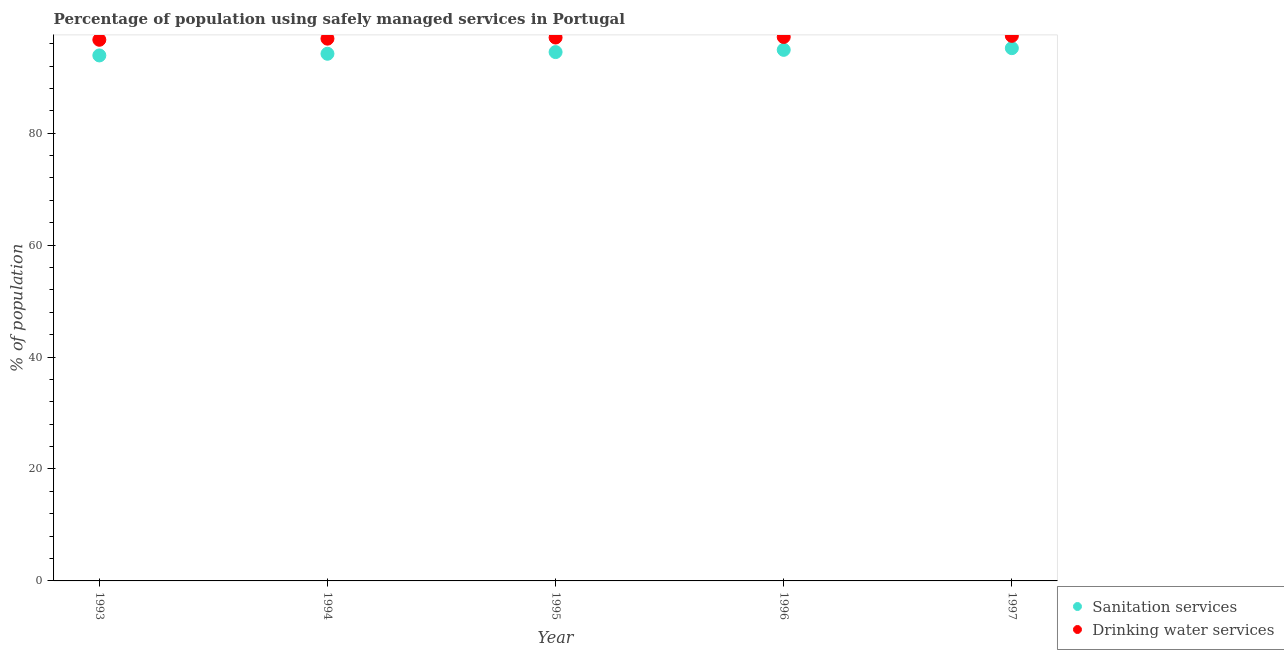How many different coloured dotlines are there?
Ensure brevity in your answer.  2. Is the number of dotlines equal to the number of legend labels?
Your response must be concise. Yes. What is the percentage of population who used sanitation services in 1995?
Your answer should be compact. 94.5. Across all years, what is the maximum percentage of population who used drinking water services?
Your response must be concise. 97.4. Across all years, what is the minimum percentage of population who used sanitation services?
Provide a succinct answer. 93.9. In which year was the percentage of population who used sanitation services maximum?
Provide a succinct answer. 1997. What is the total percentage of population who used drinking water services in the graph?
Give a very brief answer. 485.3. What is the difference between the percentage of population who used sanitation services in 1995 and that in 1996?
Give a very brief answer. -0.4. What is the difference between the percentage of population who used sanitation services in 1993 and the percentage of population who used drinking water services in 1996?
Your response must be concise. -3.3. What is the average percentage of population who used sanitation services per year?
Offer a very short reply. 94.54. In the year 1996, what is the difference between the percentage of population who used drinking water services and percentage of population who used sanitation services?
Your response must be concise. 2.3. In how many years, is the percentage of population who used sanitation services greater than 56 %?
Ensure brevity in your answer.  5. What is the ratio of the percentage of population who used drinking water services in 1994 to that in 1997?
Ensure brevity in your answer.  0.99. Is the percentage of population who used sanitation services in 1993 less than that in 1996?
Make the answer very short. Yes. Is the difference between the percentage of population who used sanitation services in 1993 and 1996 greater than the difference between the percentage of population who used drinking water services in 1993 and 1996?
Keep it short and to the point. No. What is the difference between the highest and the second highest percentage of population who used sanitation services?
Give a very brief answer. 0.3. What is the difference between the highest and the lowest percentage of population who used drinking water services?
Give a very brief answer. 0.7. In how many years, is the percentage of population who used drinking water services greater than the average percentage of population who used drinking water services taken over all years?
Ensure brevity in your answer.  3. Is the sum of the percentage of population who used drinking water services in 1994 and 1996 greater than the maximum percentage of population who used sanitation services across all years?
Offer a terse response. Yes. Is the percentage of population who used sanitation services strictly less than the percentage of population who used drinking water services over the years?
Your answer should be compact. Yes. How many years are there in the graph?
Your answer should be compact. 5. What is the difference between two consecutive major ticks on the Y-axis?
Your answer should be compact. 20. Are the values on the major ticks of Y-axis written in scientific E-notation?
Offer a very short reply. No. Does the graph contain any zero values?
Your answer should be very brief. No. Where does the legend appear in the graph?
Keep it short and to the point. Bottom right. How many legend labels are there?
Make the answer very short. 2. How are the legend labels stacked?
Ensure brevity in your answer.  Vertical. What is the title of the graph?
Keep it short and to the point. Percentage of population using safely managed services in Portugal. What is the label or title of the Y-axis?
Provide a succinct answer. % of population. What is the % of population of Sanitation services in 1993?
Offer a terse response. 93.9. What is the % of population in Drinking water services in 1993?
Your response must be concise. 96.7. What is the % of population in Sanitation services in 1994?
Make the answer very short. 94.2. What is the % of population in Drinking water services in 1994?
Keep it short and to the point. 96.9. What is the % of population in Sanitation services in 1995?
Keep it short and to the point. 94.5. What is the % of population of Drinking water services in 1995?
Offer a very short reply. 97.1. What is the % of population of Sanitation services in 1996?
Give a very brief answer. 94.9. What is the % of population in Drinking water services in 1996?
Provide a short and direct response. 97.2. What is the % of population in Sanitation services in 1997?
Make the answer very short. 95.2. What is the % of population of Drinking water services in 1997?
Give a very brief answer. 97.4. Across all years, what is the maximum % of population in Sanitation services?
Provide a short and direct response. 95.2. Across all years, what is the maximum % of population of Drinking water services?
Make the answer very short. 97.4. Across all years, what is the minimum % of population in Sanitation services?
Provide a short and direct response. 93.9. Across all years, what is the minimum % of population in Drinking water services?
Give a very brief answer. 96.7. What is the total % of population in Sanitation services in the graph?
Your response must be concise. 472.7. What is the total % of population of Drinking water services in the graph?
Make the answer very short. 485.3. What is the difference between the % of population in Sanitation services in 1993 and that in 1994?
Offer a very short reply. -0.3. What is the difference between the % of population of Sanitation services in 1993 and that in 1995?
Provide a short and direct response. -0.6. What is the difference between the % of population of Drinking water services in 1993 and that in 1995?
Ensure brevity in your answer.  -0.4. What is the difference between the % of population of Sanitation services in 1993 and that in 1996?
Your answer should be very brief. -1. What is the difference between the % of population of Sanitation services in 1994 and that in 1995?
Your response must be concise. -0.3. What is the difference between the % of population in Sanitation services in 1994 and that in 1996?
Your answer should be compact. -0.7. What is the difference between the % of population in Sanitation services in 1994 and that in 1997?
Make the answer very short. -1. What is the difference between the % of population of Drinking water services in 1994 and that in 1997?
Offer a very short reply. -0.5. What is the difference between the % of population in Sanitation services in 1996 and that in 1997?
Your answer should be compact. -0.3. What is the difference between the % of population in Drinking water services in 1996 and that in 1997?
Your answer should be very brief. -0.2. What is the difference between the % of population of Sanitation services in 1993 and the % of population of Drinking water services in 1995?
Ensure brevity in your answer.  -3.2. What is the difference between the % of population of Sanitation services in 1993 and the % of population of Drinking water services in 1996?
Ensure brevity in your answer.  -3.3. What is the difference between the % of population in Sanitation services in 1993 and the % of population in Drinking water services in 1997?
Provide a short and direct response. -3.5. What is the difference between the % of population of Sanitation services in 1994 and the % of population of Drinking water services in 1996?
Your response must be concise. -3. What is the difference between the % of population of Sanitation services in 1995 and the % of population of Drinking water services in 1996?
Provide a short and direct response. -2.7. What is the difference between the % of population in Sanitation services in 1995 and the % of population in Drinking water services in 1997?
Offer a very short reply. -2.9. What is the average % of population in Sanitation services per year?
Ensure brevity in your answer.  94.54. What is the average % of population of Drinking water services per year?
Offer a very short reply. 97.06. In the year 1993, what is the difference between the % of population in Sanitation services and % of population in Drinking water services?
Your answer should be very brief. -2.8. In the year 1997, what is the difference between the % of population of Sanitation services and % of population of Drinking water services?
Keep it short and to the point. -2.2. What is the ratio of the % of population in Sanitation services in 1993 to that in 1995?
Offer a very short reply. 0.99. What is the ratio of the % of population of Drinking water services in 1993 to that in 1995?
Your answer should be compact. 1. What is the ratio of the % of population in Drinking water services in 1993 to that in 1996?
Provide a succinct answer. 0.99. What is the ratio of the % of population of Sanitation services in 1993 to that in 1997?
Provide a short and direct response. 0.99. What is the ratio of the % of population in Drinking water services in 1993 to that in 1997?
Make the answer very short. 0.99. What is the ratio of the % of population of Sanitation services in 1994 to that in 1995?
Your answer should be compact. 1. What is the ratio of the % of population of Drinking water services in 1994 to that in 1995?
Offer a very short reply. 1. What is the ratio of the % of population of Drinking water services in 1994 to that in 1996?
Your response must be concise. 1. What is the ratio of the % of population in Sanitation services in 1994 to that in 1997?
Provide a short and direct response. 0.99. What is the ratio of the % of population of Drinking water services in 1994 to that in 1997?
Your answer should be very brief. 0.99. What is the ratio of the % of population in Sanitation services in 1995 to that in 1996?
Offer a very short reply. 1. What is the ratio of the % of population in Drinking water services in 1995 to that in 1996?
Keep it short and to the point. 1. What is the ratio of the % of population of Sanitation services in 1996 to that in 1997?
Offer a terse response. 1. What is the ratio of the % of population in Drinking water services in 1996 to that in 1997?
Offer a terse response. 1. What is the difference between the highest and the second highest % of population in Sanitation services?
Ensure brevity in your answer.  0.3. What is the difference between the highest and the lowest % of population in Sanitation services?
Offer a very short reply. 1.3. 